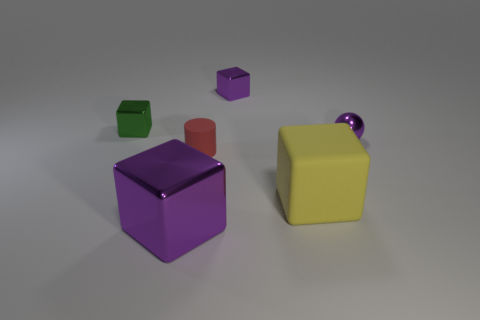What material is the big yellow object that is the same shape as the green shiny object?
Your answer should be very brief. Rubber. Is the number of metallic objects to the left of the matte block greater than the number of purple metallic spheres left of the small purple shiny ball?
Your answer should be very brief. Yes. What is the shape of the large thing that is the same material as the tiny green thing?
Offer a terse response. Cube. Is the number of objects to the right of the purple metallic ball greater than the number of brown rubber spheres?
Offer a very short reply. No. How many tiny cylinders are the same color as the small metal sphere?
Your response must be concise. 0. How many other objects are there of the same color as the tiny matte cylinder?
Your answer should be compact. 0. Are there more small red things than red metal cubes?
Provide a short and direct response. Yes. What is the large yellow cube made of?
Provide a short and direct response. Rubber. Does the rubber thing that is behind the matte cube have the same size as the big shiny block?
Ensure brevity in your answer.  No. What is the size of the object that is on the left side of the big purple object?
Give a very brief answer. Small. 